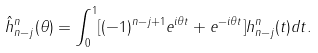<formula> <loc_0><loc_0><loc_500><loc_500>\hat { h } ^ { n } _ { n - j } ( \theta ) = \int _ { 0 } ^ { 1 } [ ( - 1 ) ^ { n - j + 1 } e ^ { i \theta t } + e ^ { - i \theta t } ] h ^ { n } _ { n - j } ( t ) d t .</formula> 